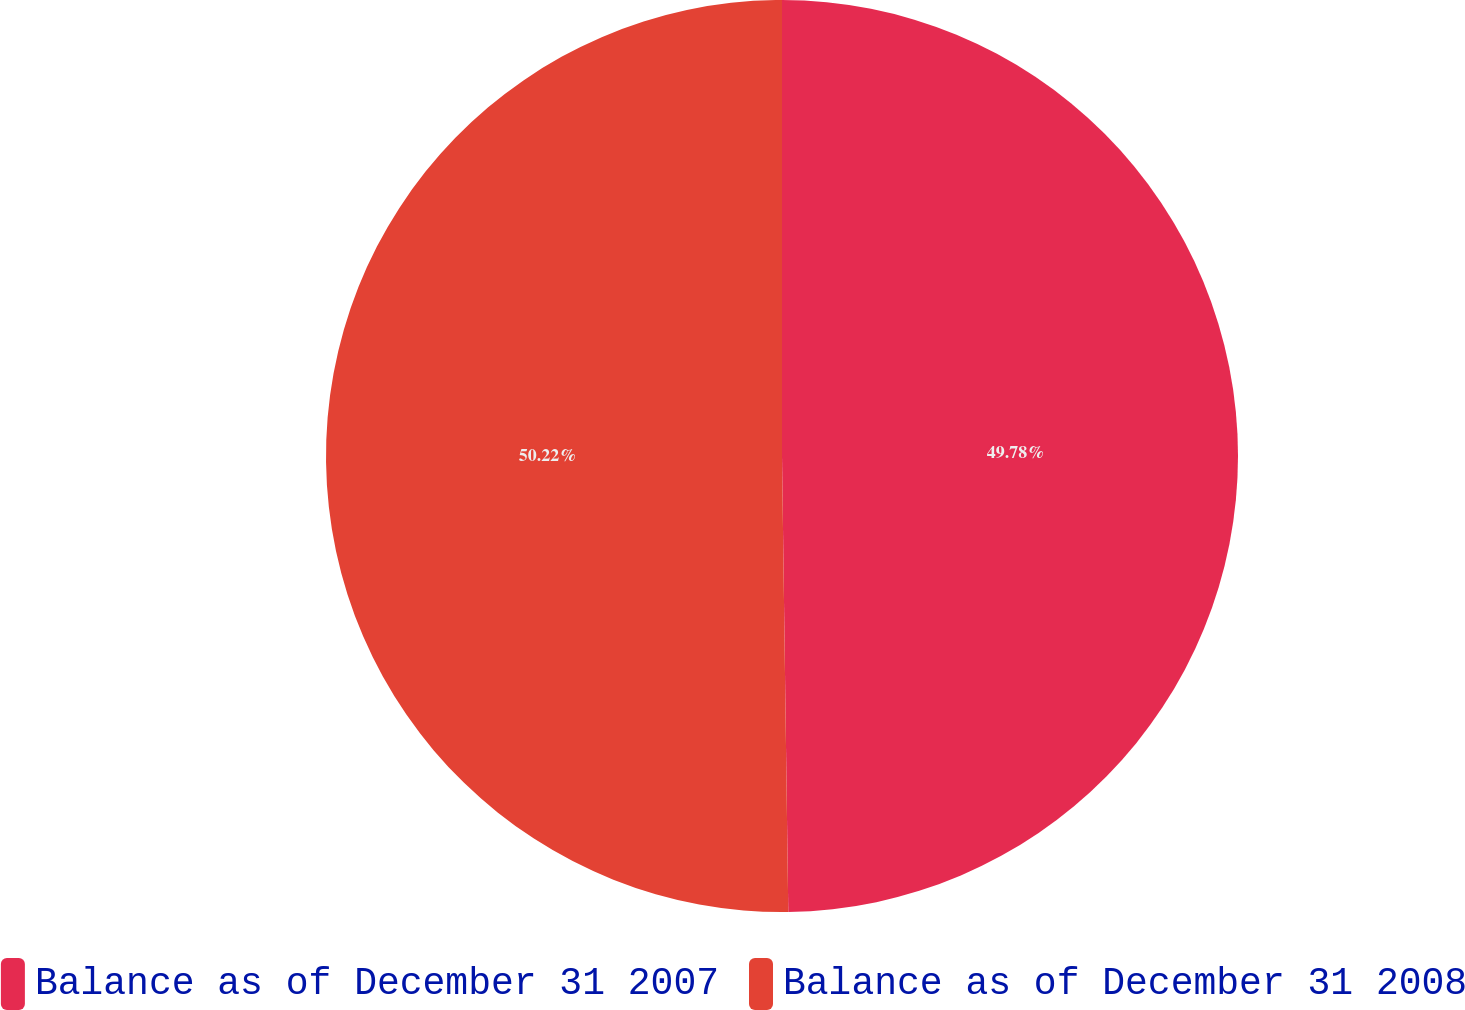Convert chart. <chart><loc_0><loc_0><loc_500><loc_500><pie_chart><fcel>Balance as of December 31 2007<fcel>Balance as of December 31 2008<nl><fcel>49.78%<fcel>50.22%<nl></chart> 